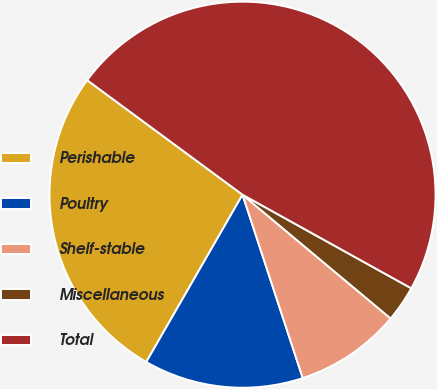Convert chart. <chart><loc_0><loc_0><loc_500><loc_500><pie_chart><fcel>Perishable<fcel>Poultry<fcel>Shelf-stable<fcel>Miscellaneous<fcel>Total<nl><fcel>26.8%<fcel>13.36%<fcel>8.87%<fcel>3.02%<fcel>47.95%<nl></chart> 